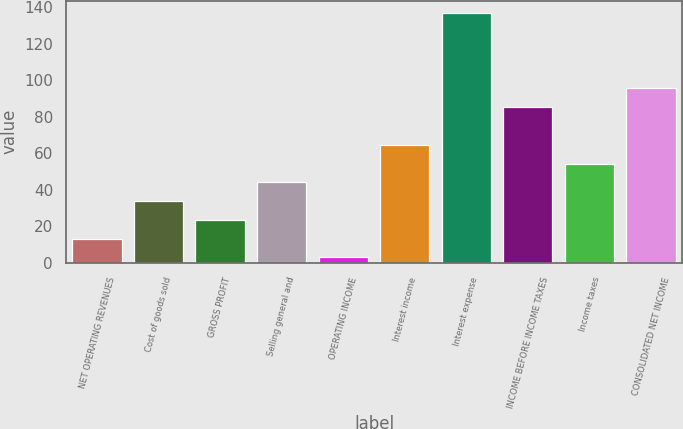Convert chart to OTSL. <chart><loc_0><loc_0><loc_500><loc_500><bar_chart><fcel>NET OPERATING REVENUES<fcel>Cost of goods sold<fcel>GROSS PROFIT<fcel>Selling general and<fcel>OPERATING INCOME<fcel>Interest income<fcel>Interest expense<fcel>INCOME BEFORE INCOME TAXES<fcel>Income taxes<fcel>CONSOLIDATED NET INCOME<nl><fcel>13.3<fcel>33.9<fcel>23.6<fcel>44.2<fcel>3<fcel>64.8<fcel>136.9<fcel>85.4<fcel>54.5<fcel>95.7<nl></chart> 